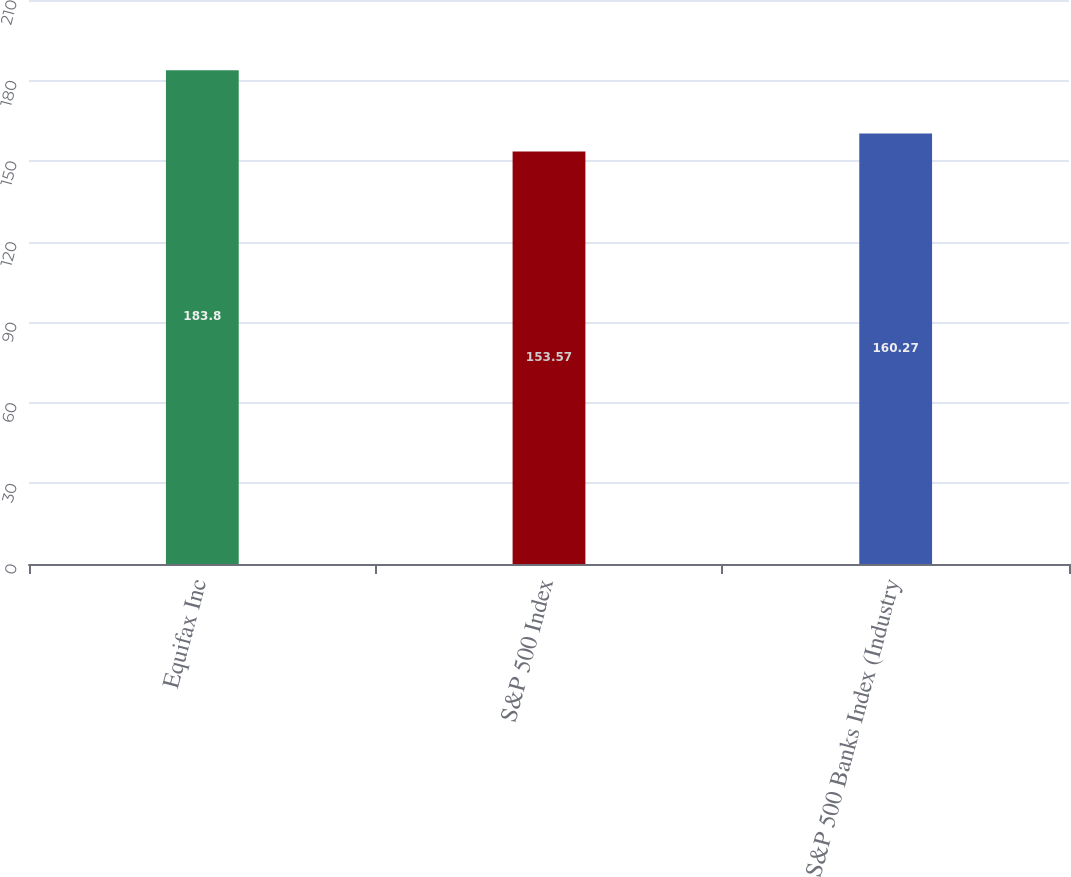Convert chart. <chart><loc_0><loc_0><loc_500><loc_500><bar_chart><fcel>Equifax Inc<fcel>S&P 500 Index<fcel>S&P 500 Banks Index (Industry<nl><fcel>183.8<fcel>153.57<fcel>160.27<nl></chart> 